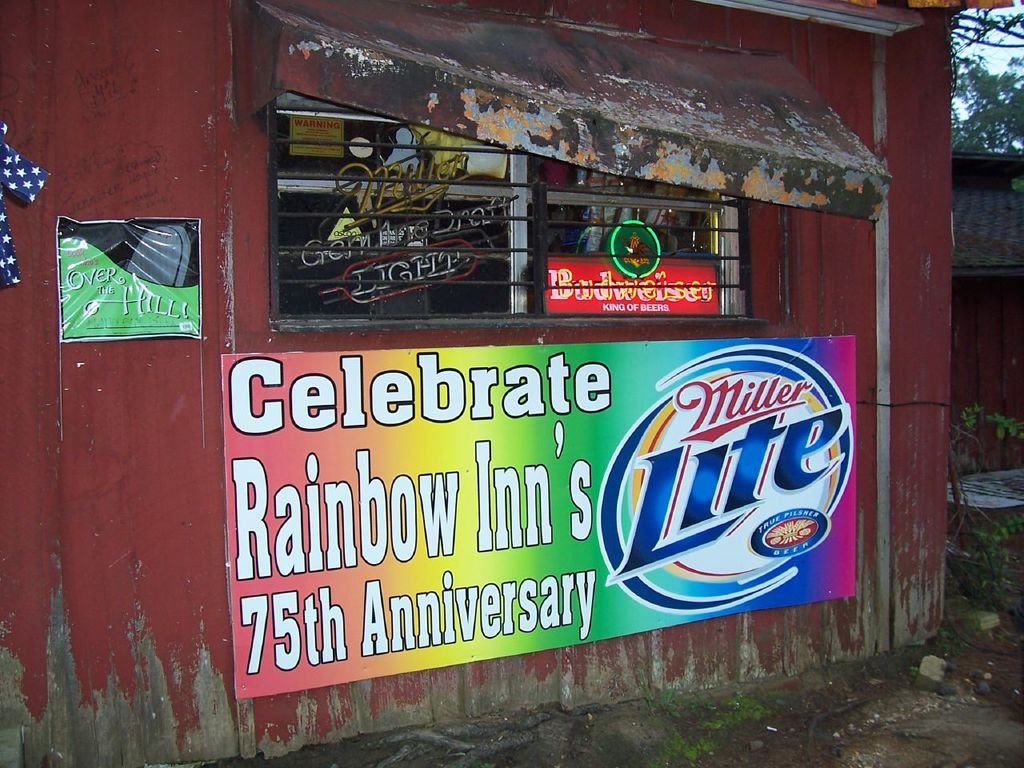What does the 'Over the Hill' sign signify in this context? "Over the Hill" is often used to denote surpassing middle age, generally marked as a humorous or celebratory acknowledgment of aging. Within the context of this image, it could be indicating a theme of celebrating longevity, not just of individuals but of the establishment itself, aligning with the 75th-anniversary celebration. This sign adds a playful, relatable touch to the scene, emphasizing communal and celebratory values of the locale. 